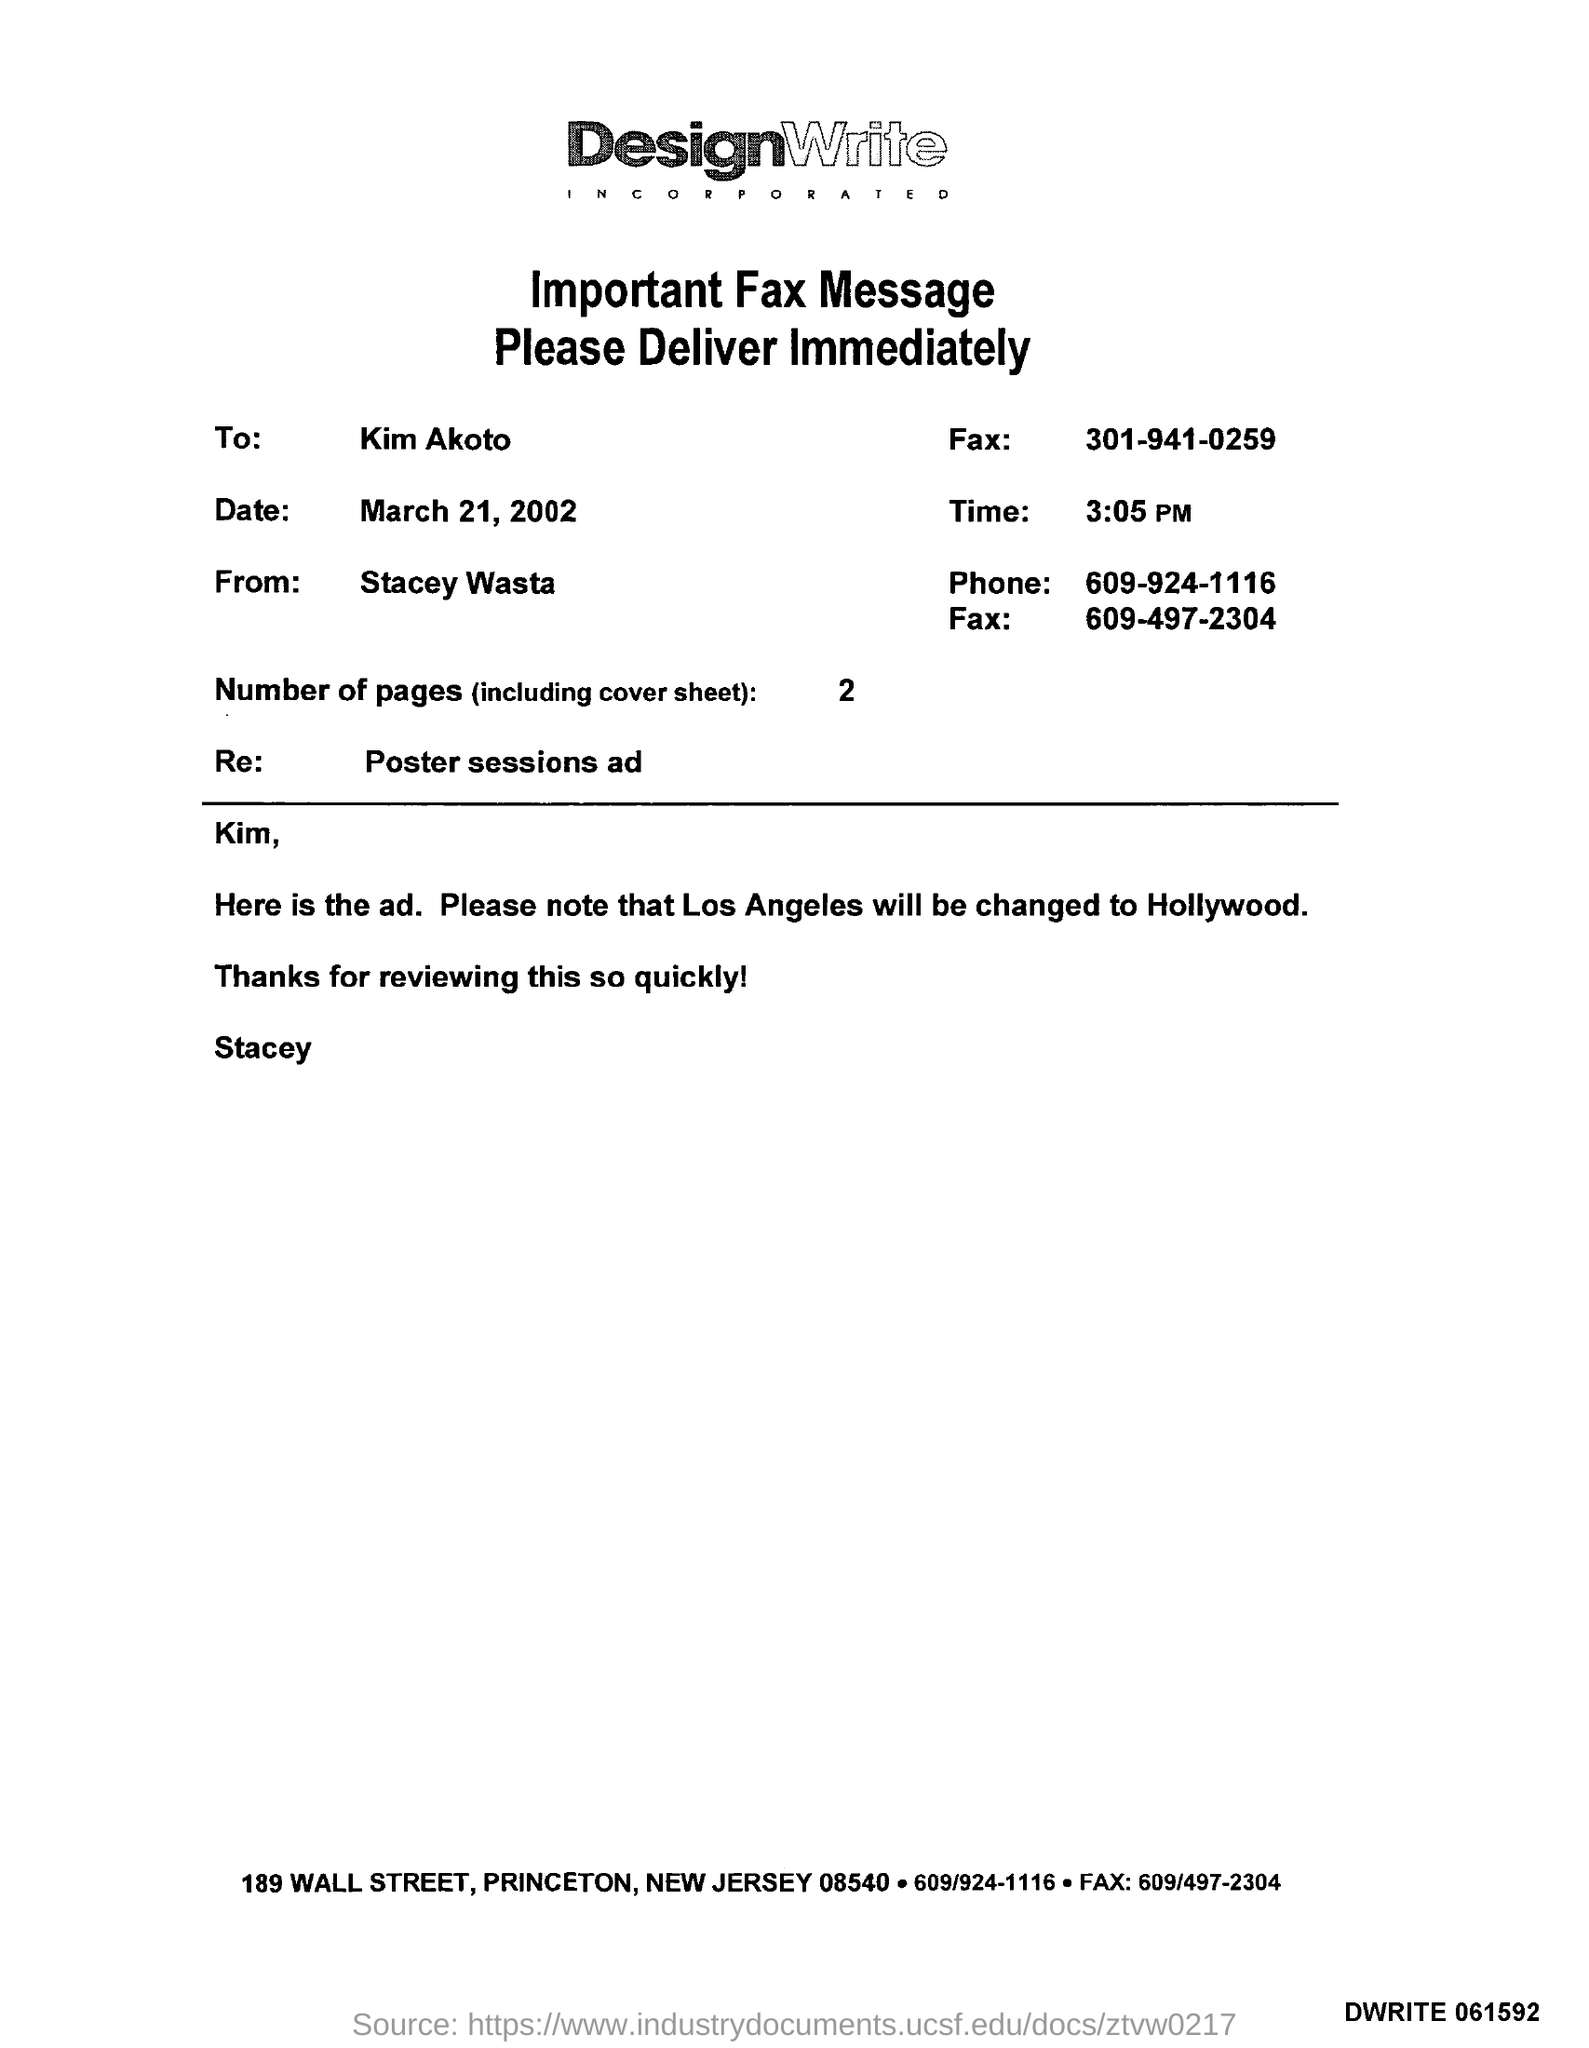Give some essential details in this illustration. The number of pages is 2, ranging from 1 to 5. It is predicted that Los Angeles will undergo a significant change, and it will be transformed into a place known as Hollywood. The date is March 21, 2002. The phone number is 609-924-1116. What is the Re?" is a poster session and discussion event hosted by the Repository Evaluation Workflow (REW) group, which focuses on evaluating and improving repository workflows for scientific research. 